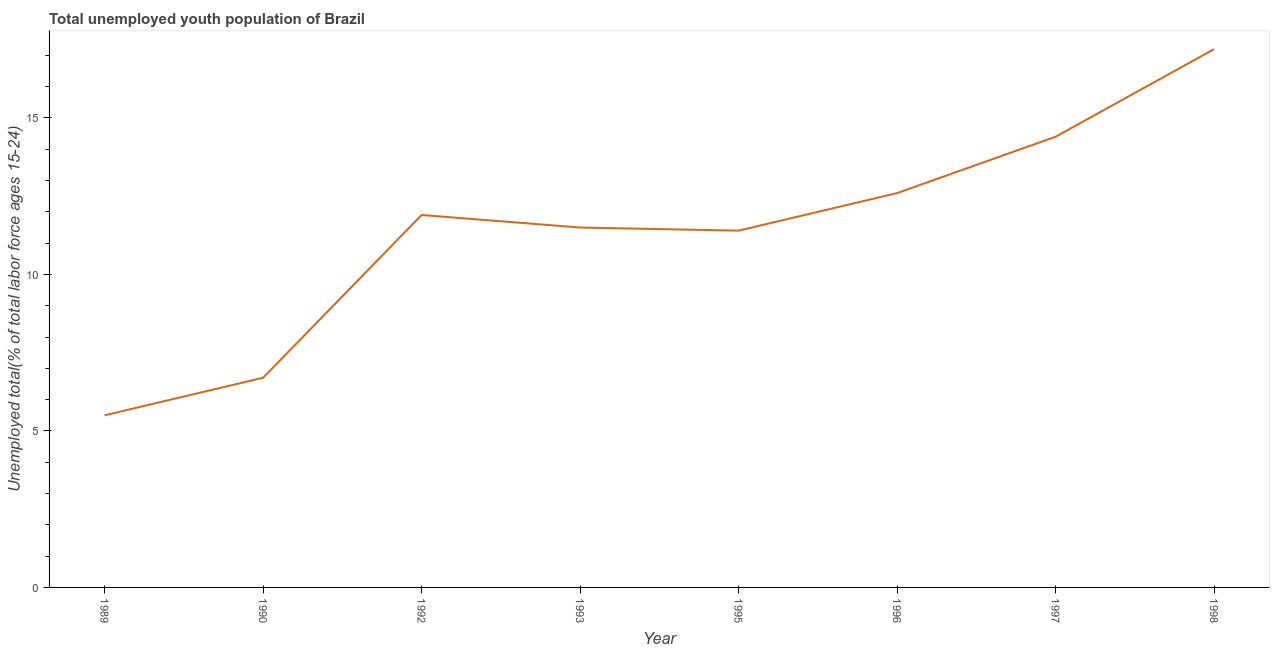Across all years, what is the maximum unemployed youth?
Your response must be concise. 17.2. In which year was the unemployed youth maximum?
Ensure brevity in your answer.  1998. In which year was the unemployed youth minimum?
Ensure brevity in your answer.  1989. What is the sum of the unemployed youth?
Offer a terse response. 91.2. What is the difference between the unemployed youth in 1990 and 1993?
Make the answer very short. -4.8. What is the average unemployed youth per year?
Offer a very short reply. 11.4. What is the median unemployed youth?
Your answer should be compact. 11.7. In how many years, is the unemployed youth greater than 10 %?
Your response must be concise. 6. Do a majority of the years between 1998 and 1992 (inclusive) have unemployed youth greater than 1 %?
Give a very brief answer. Yes. What is the ratio of the unemployed youth in 1990 to that in 1997?
Give a very brief answer. 0.47. Is the unemployed youth in 1993 less than that in 1998?
Your answer should be very brief. Yes. What is the difference between the highest and the second highest unemployed youth?
Provide a short and direct response. 2.8. Is the sum of the unemployed youth in 1990 and 1998 greater than the maximum unemployed youth across all years?
Your response must be concise. Yes. What is the difference between the highest and the lowest unemployed youth?
Your answer should be very brief. 11.7. In how many years, is the unemployed youth greater than the average unemployed youth taken over all years?
Give a very brief answer. 5. Does the unemployed youth monotonically increase over the years?
Provide a short and direct response. No. How many lines are there?
Give a very brief answer. 1. How many years are there in the graph?
Your answer should be compact. 8. What is the difference between two consecutive major ticks on the Y-axis?
Give a very brief answer. 5. Are the values on the major ticks of Y-axis written in scientific E-notation?
Provide a succinct answer. No. Does the graph contain any zero values?
Provide a succinct answer. No. Does the graph contain grids?
Your response must be concise. No. What is the title of the graph?
Keep it short and to the point. Total unemployed youth population of Brazil. What is the label or title of the Y-axis?
Your response must be concise. Unemployed total(% of total labor force ages 15-24). What is the Unemployed total(% of total labor force ages 15-24) in 1990?
Your response must be concise. 6.7. What is the Unemployed total(% of total labor force ages 15-24) in 1992?
Your response must be concise. 11.9. What is the Unemployed total(% of total labor force ages 15-24) in 1993?
Offer a very short reply. 11.5. What is the Unemployed total(% of total labor force ages 15-24) of 1995?
Make the answer very short. 11.4. What is the Unemployed total(% of total labor force ages 15-24) of 1996?
Offer a terse response. 12.6. What is the Unemployed total(% of total labor force ages 15-24) in 1997?
Provide a succinct answer. 14.4. What is the Unemployed total(% of total labor force ages 15-24) of 1998?
Keep it short and to the point. 17.2. What is the difference between the Unemployed total(% of total labor force ages 15-24) in 1989 and 1992?
Your response must be concise. -6.4. What is the difference between the Unemployed total(% of total labor force ages 15-24) in 1989 and 1998?
Offer a terse response. -11.7. What is the difference between the Unemployed total(% of total labor force ages 15-24) in 1990 and 1992?
Offer a very short reply. -5.2. What is the difference between the Unemployed total(% of total labor force ages 15-24) in 1990 and 1996?
Your response must be concise. -5.9. What is the difference between the Unemployed total(% of total labor force ages 15-24) in 1990 and 1997?
Give a very brief answer. -7.7. What is the difference between the Unemployed total(% of total labor force ages 15-24) in 1990 and 1998?
Give a very brief answer. -10.5. What is the difference between the Unemployed total(% of total labor force ages 15-24) in 1992 and 1995?
Offer a terse response. 0.5. What is the difference between the Unemployed total(% of total labor force ages 15-24) in 1993 and 1995?
Keep it short and to the point. 0.1. What is the difference between the Unemployed total(% of total labor force ages 15-24) in 1993 and 1997?
Provide a succinct answer. -2.9. What is the difference between the Unemployed total(% of total labor force ages 15-24) in 1993 and 1998?
Provide a succinct answer. -5.7. What is the difference between the Unemployed total(% of total labor force ages 15-24) in 1995 and 1996?
Keep it short and to the point. -1.2. What is the difference between the Unemployed total(% of total labor force ages 15-24) in 1995 and 1997?
Make the answer very short. -3. What is the difference between the Unemployed total(% of total labor force ages 15-24) in 1995 and 1998?
Make the answer very short. -5.8. What is the difference between the Unemployed total(% of total labor force ages 15-24) in 1996 and 1997?
Offer a very short reply. -1.8. What is the ratio of the Unemployed total(% of total labor force ages 15-24) in 1989 to that in 1990?
Your answer should be very brief. 0.82. What is the ratio of the Unemployed total(% of total labor force ages 15-24) in 1989 to that in 1992?
Give a very brief answer. 0.46. What is the ratio of the Unemployed total(% of total labor force ages 15-24) in 1989 to that in 1993?
Keep it short and to the point. 0.48. What is the ratio of the Unemployed total(% of total labor force ages 15-24) in 1989 to that in 1995?
Provide a short and direct response. 0.48. What is the ratio of the Unemployed total(% of total labor force ages 15-24) in 1989 to that in 1996?
Your response must be concise. 0.44. What is the ratio of the Unemployed total(% of total labor force ages 15-24) in 1989 to that in 1997?
Your response must be concise. 0.38. What is the ratio of the Unemployed total(% of total labor force ages 15-24) in 1989 to that in 1998?
Make the answer very short. 0.32. What is the ratio of the Unemployed total(% of total labor force ages 15-24) in 1990 to that in 1992?
Your answer should be compact. 0.56. What is the ratio of the Unemployed total(% of total labor force ages 15-24) in 1990 to that in 1993?
Your answer should be very brief. 0.58. What is the ratio of the Unemployed total(% of total labor force ages 15-24) in 1990 to that in 1995?
Your response must be concise. 0.59. What is the ratio of the Unemployed total(% of total labor force ages 15-24) in 1990 to that in 1996?
Give a very brief answer. 0.53. What is the ratio of the Unemployed total(% of total labor force ages 15-24) in 1990 to that in 1997?
Your answer should be very brief. 0.47. What is the ratio of the Unemployed total(% of total labor force ages 15-24) in 1990 to that in 1998?
Offer a terse response. 0.39. What is the ratio of the Unemployed total(% of total labor force ages 15-24) in 1992 to that in 1993?
Make the answer very short. 1.03. What is the ratio of the Unemployed total(% of total labor force ages 15-24) in 1992 to that in 1995?
Give a very brief answer. 1.04. What is the ratio of the Unemployed total(% of total labor force ages 15-24) in 1992 to that in 1996?
Provide a succinct answer. 0.94. What is the ratio of the Unemployed total(% of total labor force ages 15-24) in 1992 to that in 1997?
Offer a very short reply. 0.83. What is the ratio of the Unemployed total(% of total labor force ages 15-24) in 1992 to that in 1998?
Make the answer very short. 0.69. What is the ratio of the Unemployed total(% of total labor force ages 15-24) in 1993 to that in 1995?
Your answer should be compact. 1.01. What is the ratio of the Unemployed total(% of total labor force ages 15-24) in 1993 to that in 1997?
Your answer should be very brief. 0.8. What is the ratio of the Unemployed total(% of total labor force ages 15-24) in 1993 to that in 1998?
Your response must be concise. 0.67. What is the ratio of the Unemployed total(% of total labor force ages 15-24) in 1995 to that in 1996?
Offer a terse response. 0.91. What is the ratio of the Unemployed total(% of total labor force ages 15-24) in 1995 to that in 1997?
Offer a very short reply. 0.79. What is the ratio of the Unemployed total(% of total labor force ages 15-24) in 1995 to that in 1998?
Your answer should be very brief. 0.66. What is the ratio of the Unemployed total(% of total labor force ages 15-24) in 1996 to that in 1997?
Provide a succinct answer. 0.88. What is the ratio of the Unemployed total(% of total labor force ages 15-24) in 1996 to that in 1998?
Keep it short and to the point. 0.73. What is the ratio of the Unemployed total(% of total labor force ages 15-24) in 1997 to that in 1998?
Your response must be concise. 0.84. 